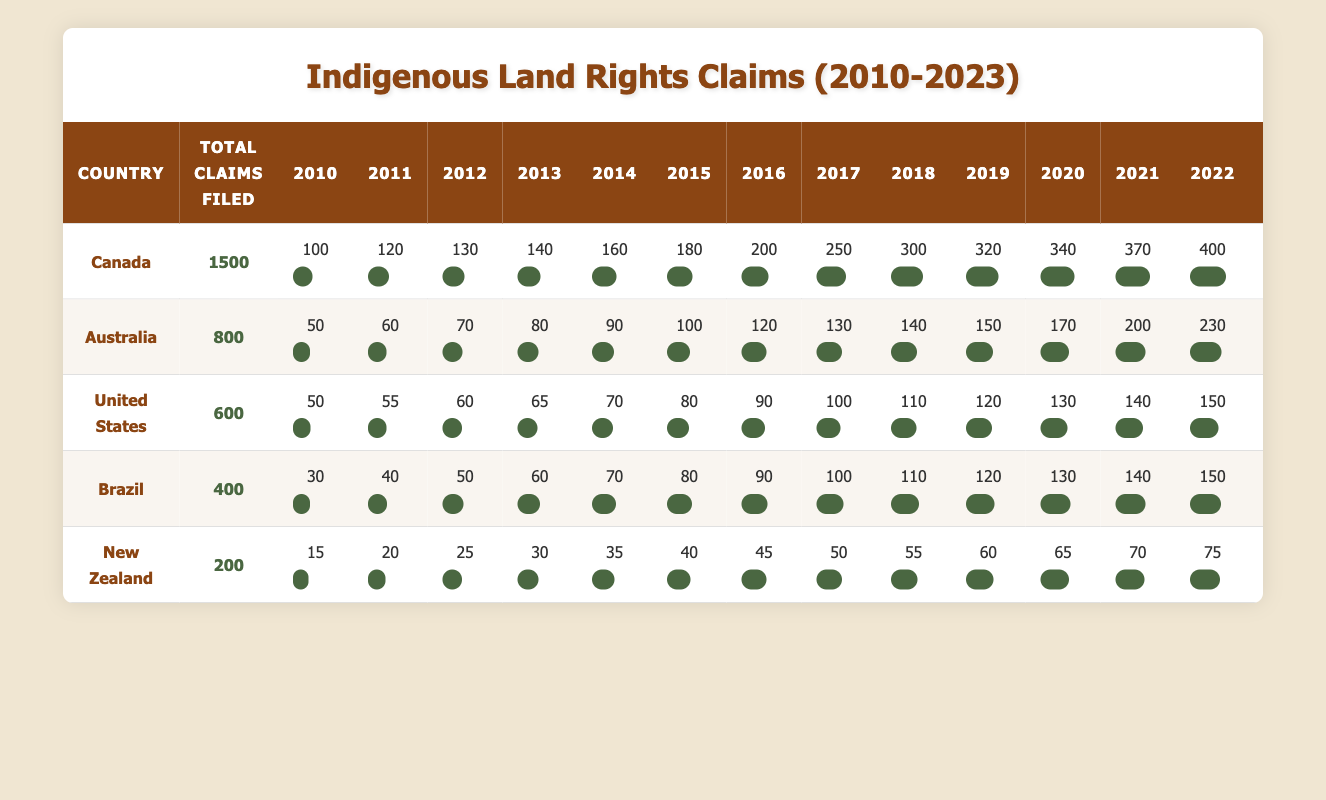What country filed the most indigenous land rights claims from 2010 to 2023? By examining the "Total Claims Filed" column, Canada has the highest number of total claims with 1500.
Answer: Canada In which year did Australia file the highest number of indigenous land rights claims? Looking at the yearly breakdown for Australia, 2022 shows the highest number of claims filed, which is 230.
Answer: 2022 What is the difference in total claims filed between Canada and the United States? Canada has filed a total of 1500 claims, while the United States has filed 600 claims. The difference is 1500 - 600 = 900.
Answer: 900 Did Brazil file more claims in 2023 than in 2010? For Brazil, the claims filed in 2023 is 160, and in 2010 it was 30. Since 160 is greater than 30, the statement is true.
Answer: Yes What is the average number of claims filed per year for New Zealand from 2010 to 2023? Summing up the claims from 2010 to 2023 gives a total of 15 + 20 + 25 + 30 + 35 + 40 + 45 + 50 + 55 + 60 + 65 + 70 + 75 + 80 = 705. There are 14 years of data; thus, the average is 705 / 14 = 50.36.
Answer: 50.36 Which country has the lowest total claims filed and what is that number? The "Total Claims Filed" column indicates that New Zealand has the lowest claims at 200.
Answer: 200 In which year did the United States experience a claim increase of at least 20 claims compared to the previous year? Upon reviewing each year's data for the United States, the years 2015 (80), 2016 (90), 2017 (100), and 2021 (140) display increases of at least 20 claims compared to the previous year.
Answer: 2015, 2016, 2017, 2021 What percentage of claims filed in total by Australia were filed in 2020? Australia filed 800 total claims and 170 in 2020. To find the percentage, the calculation is (170 / 800) × 100 = 21.25%.
Answer: 21.25% 